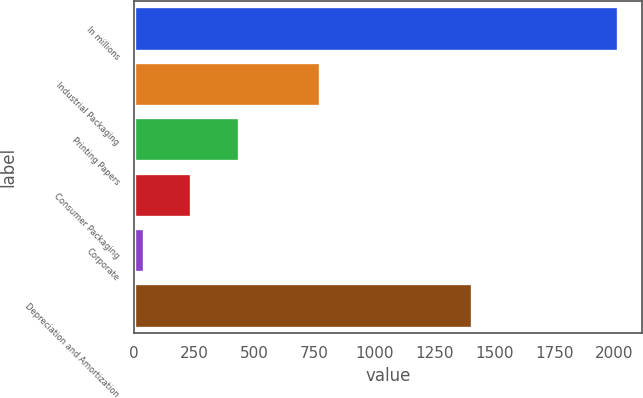Convert chart to OTSL. <chart><loc_0><loc_0><loc_500><loc_500><bar_chart><fcel>In millions<fcel>Industrial Packaging<fcel>Printing Papers<fcel>Consumer Packaging<fcel>Corporate<fcel>Depreciation and Amortization<nl><fcel>2014<fcel>775<fcel>435.6<fcel>238.3<fcel>41<fcel>1406<nl></chart> 